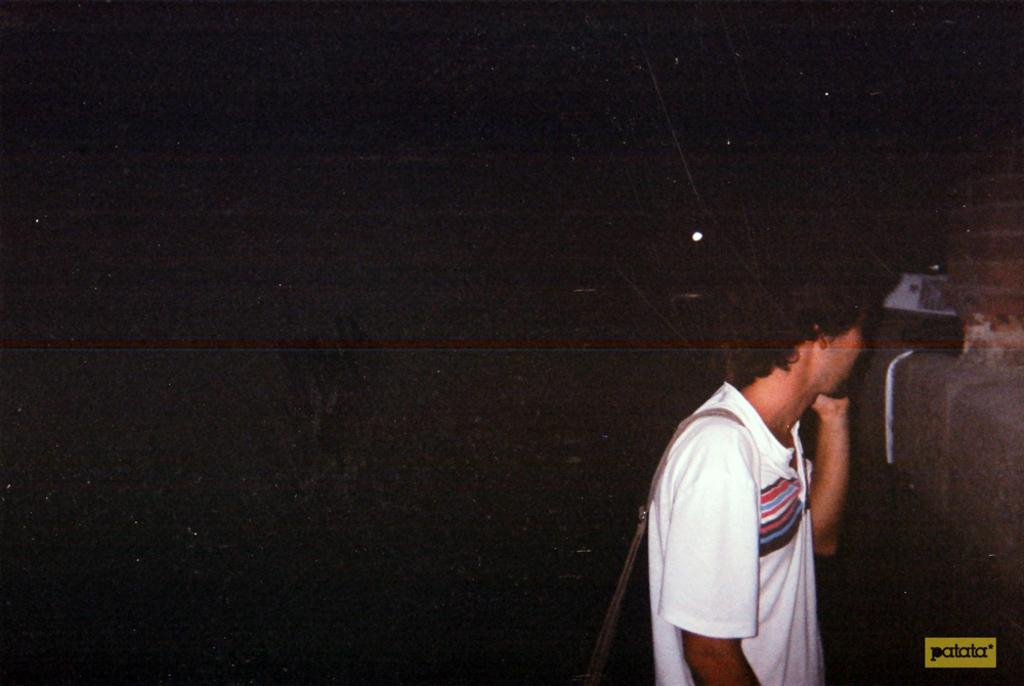What can be seen in the image? There is a person in the image. What is the person wearing? The person is wearing a white T-shirt. What is the person holding in the image? The person is holding a bag on his shoulders. What is visible on the right side of the image? There is a wall on the right side of the image. How would you describe the background of the image? The background of the image is completely dark. What type of sail can be seen in the image? There is no sail present in the image. What is the weight of the crime scene in the image? There is no crime scene present in the image, and therefore no weight can be determined. 